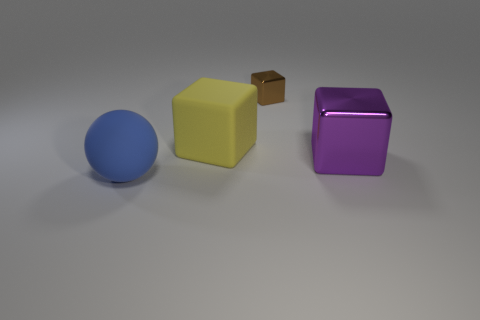What number of large matte objects have the same shape as the purple shiny thing?
Provide a short and direct response. 1. What size is the matte cube that is behind the metal cube on the right side of the brown metallic object?
Offer a terse response. Large. Is the color of the big rubber thing that is in front of the large yellow thing the same as the big cube that is left of the small brown metal object?
Offer a very short reply. No. How many large blue rubber balls are in front of the matte thing behind the big block on the right side of the brown metal object?
Your answer should be very brief. 1. How many blocks are in front of the brown shiny thing and behind the big purple object?
Your response must be concise. 1. Are there more small things that are on the left side of the matte sphere than small yellow spheres?
Your response must be concise. No. What number of blue matte spheres are the same size as the blue matte thing?
Your answer should be very brief. 0. How many large objects are cyan cubes or rubber objects?
Make the answer very short. 2. How many brown metallic balls are there?
Your answer should be very brief. 0. Are there an equal number of cubes that are on the right side of the yellow matte object and rubber balls on the right side of the purple metal cube?
Ensure brevity in your answer.  No. 